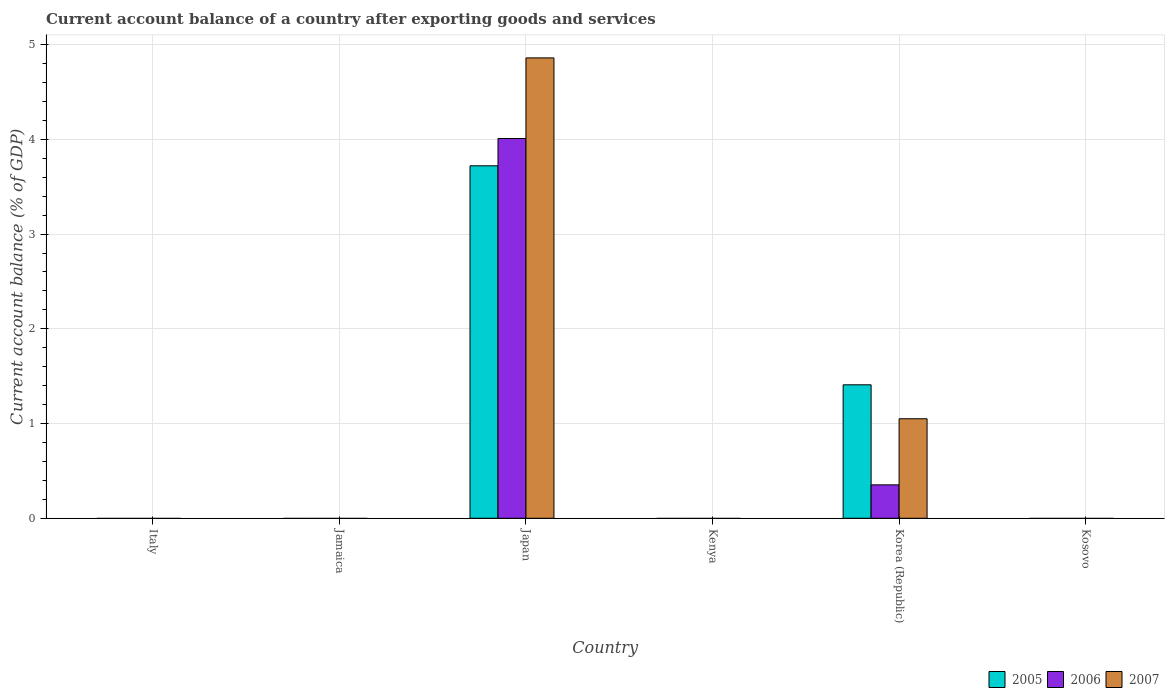How many different coloured bars are there?
Offer a terse response. 3. What is the label of the 6th group of bars from the left?
Keep it short and to the point. Kosovo. What is the account balance in 2006 in Japan?
Ensure brevity in your answer.  4.01. Across all countries, what is the maximum account balance in 2005?
Ensure brevity in your answer.  3.72. What is the total account balance in 2005 in the graph?
Offer a very short reply. 5.13. What is the difference between the account balance in 2005 in Kosovo and the account balance in 2006 in Kenya?
Make the answer very short. 0. What is the average account balance in 2006 per country?
Make the answer very short. 0.73. What is the difference between the account balance of/in 2007 and account balance of/in 2006 in Korea (Republic)?
Your response must be concise. 0.7. What is the ratio of the account balance in 2005 in Japan to that in Korea (Republic)?
Your answer should be compact. 2.64. What is the difference between the highest and the lowest account balance in 2007?
Provide a short and direct response. 4.86. In how many countries, is the account balance in 2007 greater than the average account balance in 2007 taken over all countries?
Give a very brief answer. 2. What is the difference between two consecutive major ticks on the Y-axis?
Your answer should be compact. 1. Are the values on the major ticks of Y-axis written in scientific E-notation?
Offer a very short reply. No. Does the graph contain any zero values?
Offer a very short reply. Yes. How many legend labels are there?
Your answer should be compact. 3. How are the legend labels stacked?
Your answer should be compact. Horizontal. What is the title of the graph?
Offer a very short reply. Current account balance of a country after exporting goods and services. Does "1994" appear as one of the legend labels in the graph?
Provide a succinct answer. No. What is the label or title of the X-axis?
Your answer should be compact. Country. What is the label or title of the Y-axis?
Your answer should be compact. Current account balance (% of GDP). What is the Current account balance (% of GDP) in 2005 in Italy?
Your response must be concise. 0. What is the Current account balance (% of GDP) of 2006 in Italy?
Your answer should be very brief. 0. What is the Current account balance (% of GDP) of 2005 in Jamaica?
Make the answer very short. 0. What is the Current account balance (% of GDP) of 2005 in Japan?
Offer a very short reply. 3.72. What is the Current account balance (% of GDP) in 2006 in Japan?
Provide a succinct answer. 4.01. What is the Current account balance (% of GDP) of 2007 in Japan?
Give a very brief answer. 4.86. What is the Current account balance (% of GDP) of 2005 in Kenya?
Keep it short and to the point. 0. What is the Current account balance (% of GDP) of 2006 in Kenya?
Your answer should be very brief. 0. What is the Current account balance (% of GDP) in 2005 in Korea (Republic)?
Keep it short and to the point. 1.41. What is the Current account balance (% of GDP) in 2006 in Korea (Republic)?
Make the answer very short. 0.35. What is the Current account balance (% of GDP) of 2007 in Korea (Republic)?
Offer a terse response. 1.05. What is the Current account balance (% of GDP) of 2006 in Kosovo?
Provide a succinct answer. 0. What is the Current account balance (% of GDP) in 2007 in Kosovo?
Offer a very short reply. 0. Across all countries, what is the maximum Current account balance (% of GDP) of 2005?
Keep it short and to the point. 3.72. Across all countries, what is the maximum Current account balance (% of GDP) of 2006?
Your answer should be compact. 4.01. Across all countries, what is the maximum Current account balance (% of GDP) of 2007?
Make the answer very short. 4.86. Across all countries, what is the minimum Current account balance (% of GDP) of 2005?
Your response must be concise. 0. Across all countries, what is the minimum Current account balance (% of GDP) in 2006?
Make the answer very short. 0. Across all countries, what is the minimum Current account balance (% of GDP) of 2007?
Keep it short and to the point. 0. What is the total Current account balance (% of GDP) in 2005 in the graph?
Your response must be concise. 5.13. What is the total Current account balance (% of GDP) in 2006 in the graph?
Give a very brief answer. 4.36. What is the total Current account balance (% of GDP) in 2007 in the graph?
Keep it short and to the point. 5.91. What is the difference between the Current account balance (% of GDP) in 2005 in Japan and that in Korea (Republic)?
Your answer should be compact. 2.31. What is the difference between the Current account balance (% of GDP) of 2006 in Japan and that in Korea (Republic)?
Your answer should be very brief. 3.66. What is the difference between the Current account balance (% of GDP) in 2007 in Japan and that in Korea (Republic)?
Keep it short and to the point. 3.81. What is the difference between the Current account balance (% of GDP) in 2005 in Japan and the Current account balance (% of GDP) in 2006 in Korea (Republic)?
Offer a terse response. 3.37. What is the difference between the Current account balance (% of GDP) in 2005 in Japan and the Current account balance (% of GDP) in 2007 in Korea (Republic)?
Your answer should be very brief. 2.67. What is the difference between the Current account balance (% of GDP) of 2006 in Japan and the Current account balance (% of GDP) of 2007 in Korea (Republic)?
Your answer should be compact. 2.96. What is the average Current account balance (% of GDP) of 2005 per country?
Keep it short and to the point. 0.85. What is the average Current account balance (% of GDP) in 2006 per country?
Provide a short and direct response. 0.73. What is the average Current account balance (% of GDP) of 2007 per country?
Provide a succinct answer. 0.99. What is the difference between the Current account balance (% of GDP) of 2005 and Current account balance (% of GDP) of 2006 in Japan?
Give a very brief answer. -0.29. What is the difference between the Current account balance (% of GDP) in 2005 and Current account balance (% of GDP) in 2007 in Japan?
Offer a very short reply. -1.14. What is the difference between the Current account balance (% of GDP) in 2006 and Current account balance (% of GDP) in 2007 in Japan?
Keep it short and to the point. -0.85. What is the difference between the Current account balance (% of GDP) of 2005 and Current account balance (% of GDP) of 2006 in Korea (Republic)?
Offer a terse response. 1.06. What is the difference between the Current account balance (% of GDP) of 2005 and Current account balance (% of GDP) of 2007 in Korea (Republic)?
Your response must be concise. 0.36. What is the difference between the Current account balance (% of GDP) of 2006 and Current account balance (% of GDP) of 2007 in Korea (Republic)?
Give a very brief answer. -0.7. What is the ratio of the Current account balance (% of GDP) of 2005 in Japan to that in Korea (Republic)?
Keep it short and to the point. 2.64. What is the ratio of the Current account balance (% of GDP) of 2006 in Japan to that in Korea (Republic)?
Make the answer very short. 11.37. What is the ratio of the Current account balance (% of GDP) in 2007 in Japan to that in Korea (Republic)?
Offer a very short reply. 4.63. What is the difference between the highest and the lowest Current account balance (% of GDP) in 2005?
Give a very brief answer. 3.72. What is the difference between the highest and the lowest Current account balance (% of GDP) of 2006?
Provide a succinct answer. 4.01. What is the difference between the highest and the lowest Current account balance (% of GDP) of 2007?
Keep it short and to the point. 4.86. 